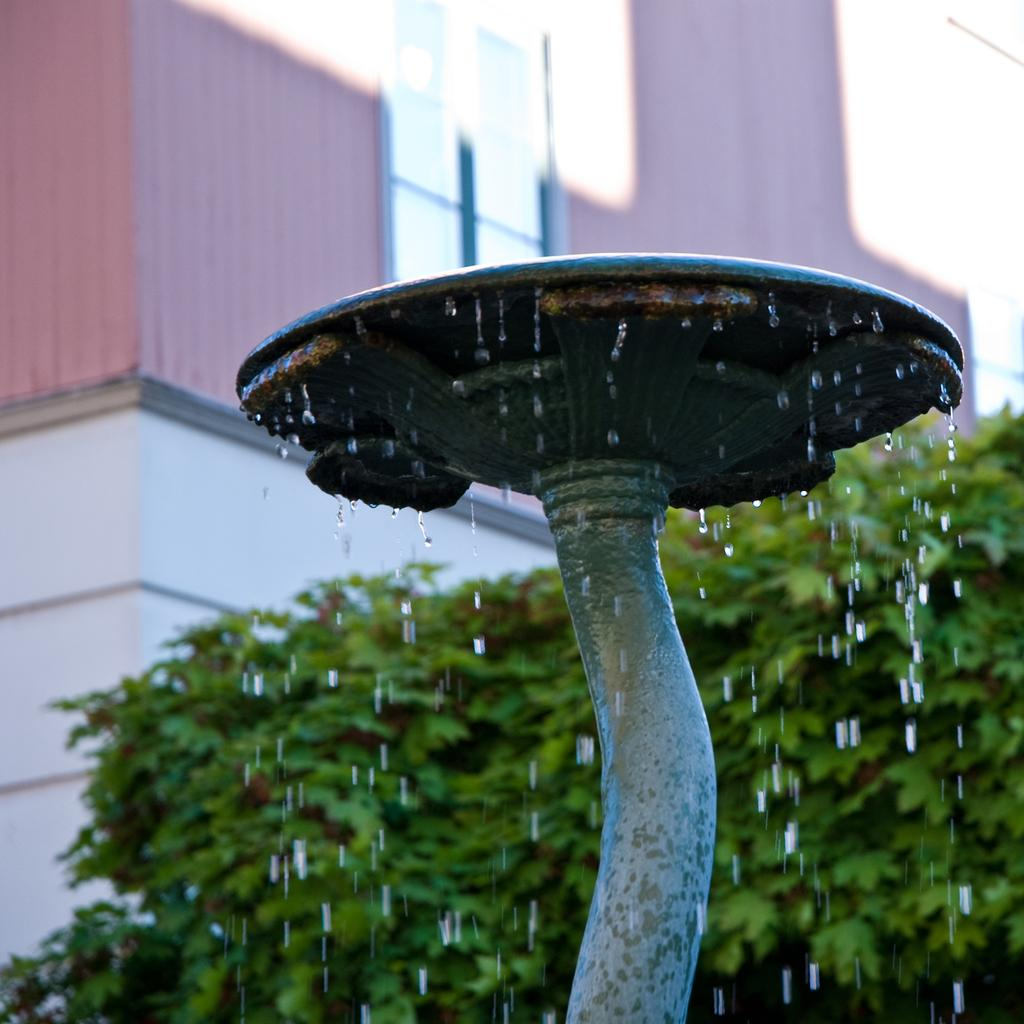What is the round shaped object connected to the pipe in the image? There is a pipe with a round shaped thing in the image. What is happening to the water from the pipe? Water is falling from the pipe in the image. What can be seen in the background of the image? There is a building and trees in the background of the image. What type of print can be seen on the trees in the background? There is no print visible on the trees in the image; they are simply trees in the background. What type of treatment is being administered to the water falling from the pipe? There is no indication of any treatment being administered to the water falling from the pipe in the image. 